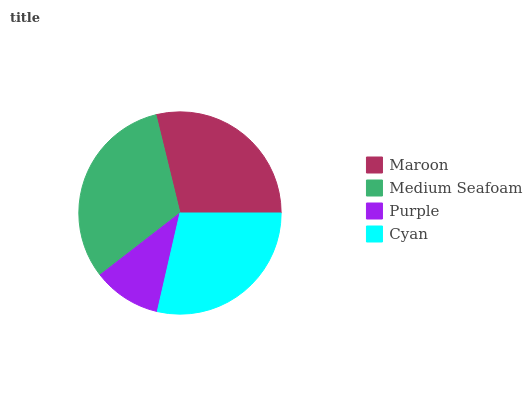Is Purple the minimum?
Answer yes or no. Yes. Is Medium Seafoam the maximum?
Answer yes or no. Yes. Is Medium Seafoam the minimum?
Answer yes or no. No. Is Purple the maximum?
Answer yes or no. No. Is Medium Seafoam greater than Purple?
Answer yes or no. Yes. Is Purple less than Medium Seafoam?
Answer yes or no. Yes. Is Purple greater than Medium Seafoam?
Answer yes or no. No. Is Medium Seafoam less than Purple?
Answer yes or no. No. Is Maroon the high median?
Answer yes or no. Yes. Is Cyan the low median?
Answer yes or no. Yes. Is Medium Seafoam the high median?
Answer yes or no. No. Is Purple the low median?
Answer yes or no. No. 